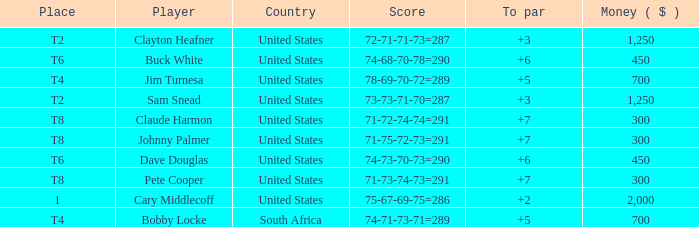What is the Johnny Palmer with a To larger than 6 Money sum? 300.0. 